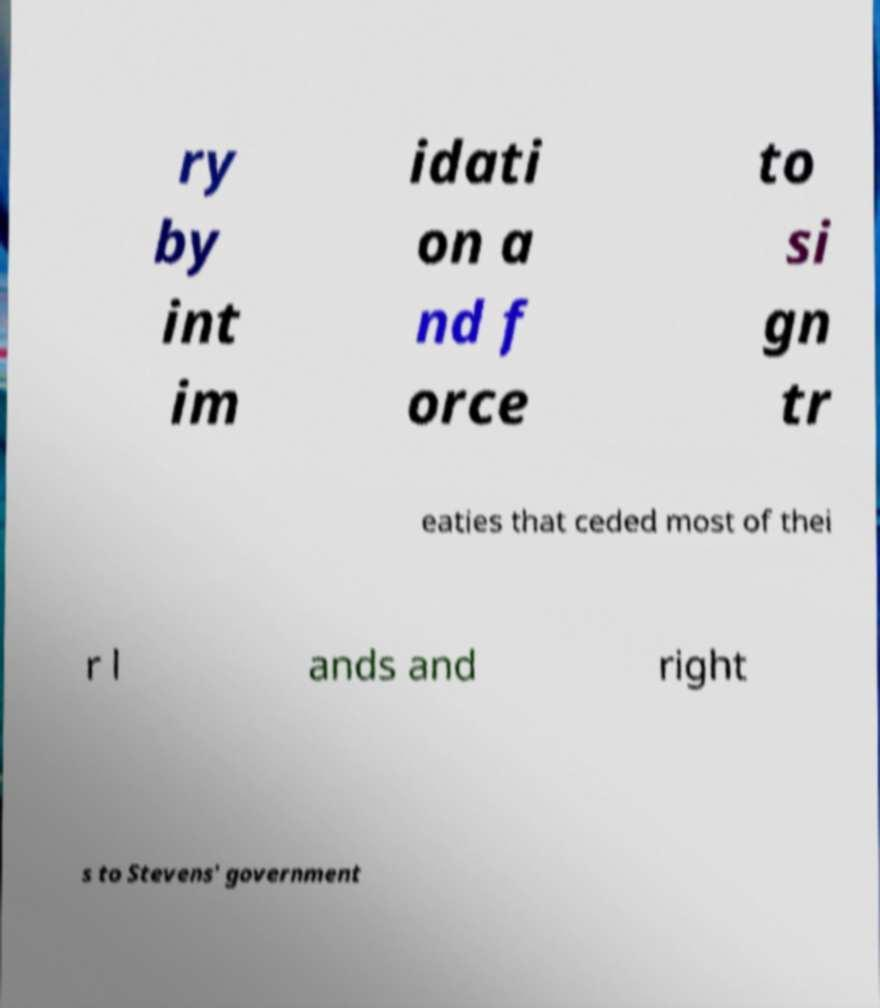Can you read and provide the text displayed in the image?This photo seems to have some interesting text. Can you extract and type it out for me? ry by int im idati on a nd f orce to si gn tr eaties that ceded most of thei r l ands and right s to Stevens' government 